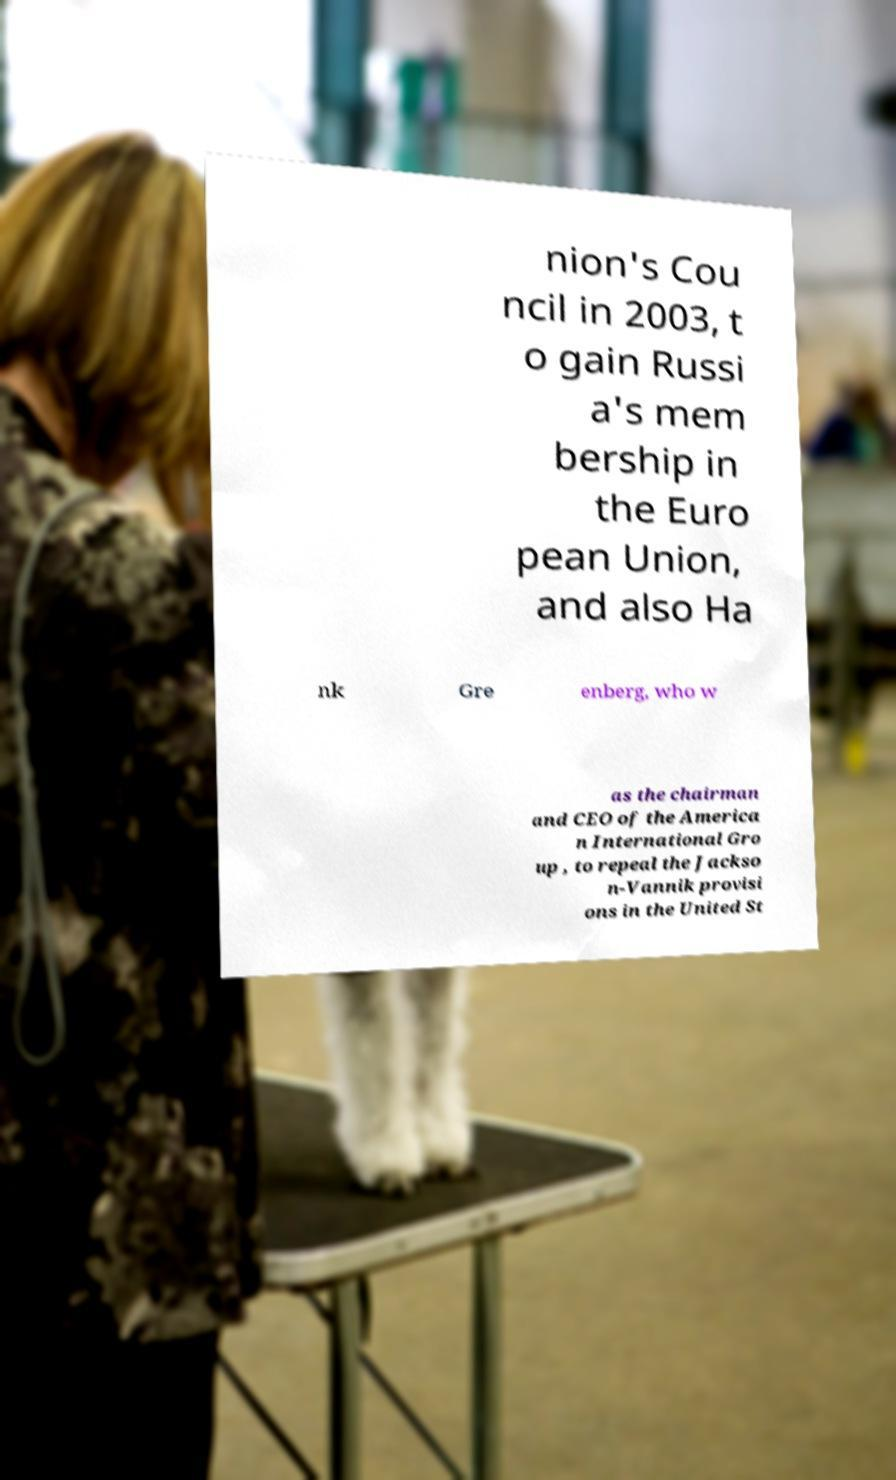Please identify and transcribe the text found in this image. nion's Cou ncil in 2003, t o gain Russi a's mem bership in the Euro pean Union, and also Ha nk Gre enberg, who w as the chairman and CEO of the America n International Gro up , to repeal the Jackso n-Vannik provisi ons in the United St 